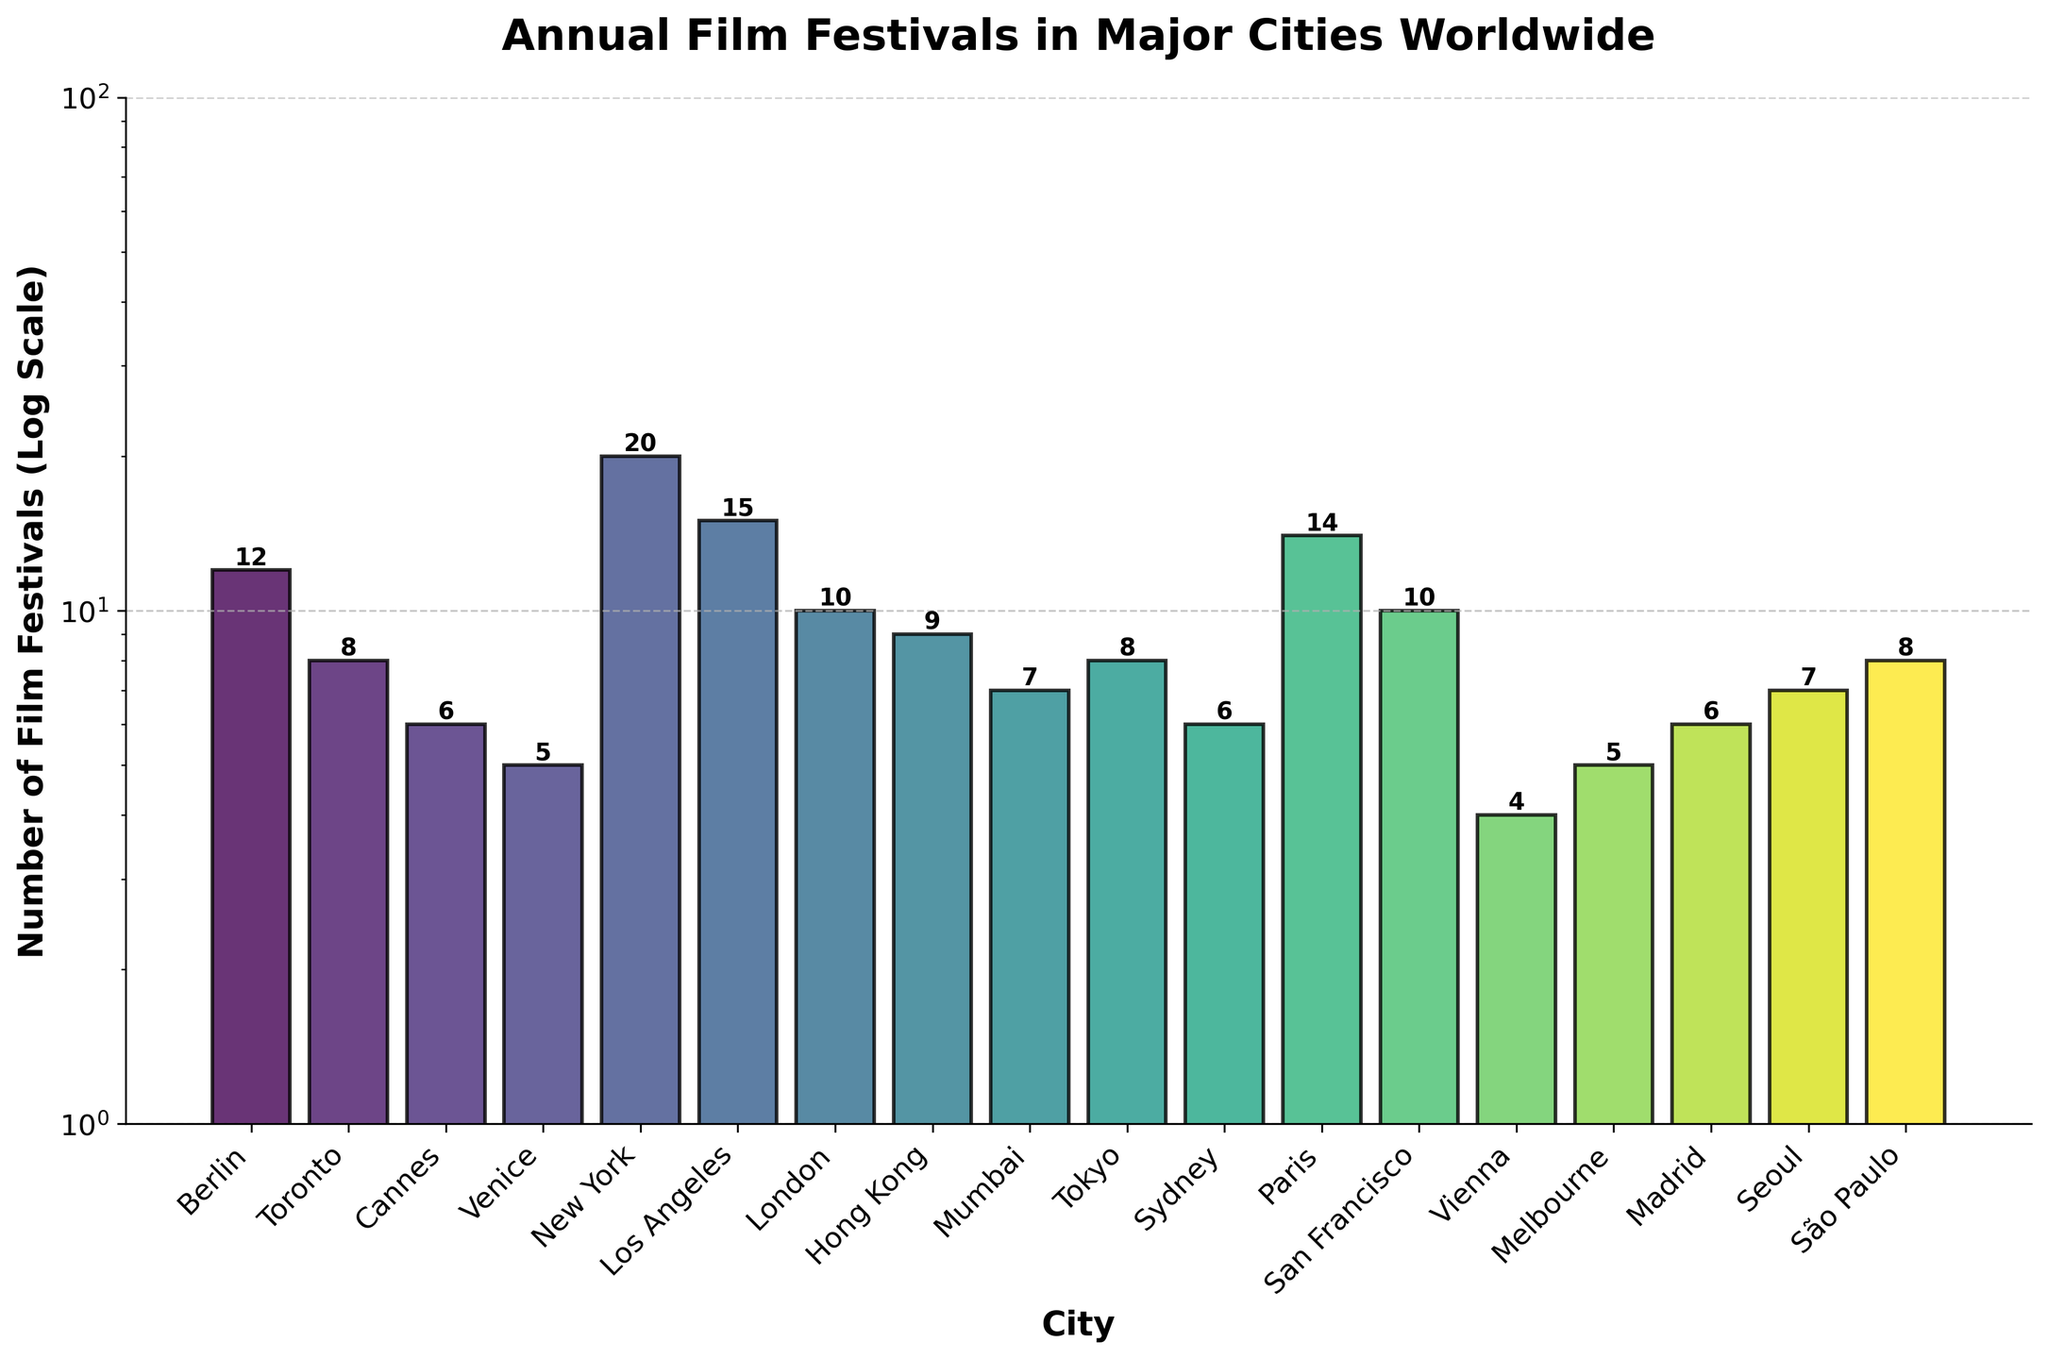What is the title of the plot? The title of the plot is displayed at the top of the figure in bold.
Answer: Annual Film Festivals in Major Cities Worldwide Which city has the highest number of film festivals annually? The tallest bar in the plot represents the city with the highest number of film festivals.
Answer: New York How many film festivals are held annually in Tokyo? The height of Tokyo's bar in the plot, along with the number label, indicates the count of film festivals.
Answer: 8 Which cities have fewer than 5 annual film festivals? Look for the bars that are below the '5' mark on the y-axis.
Answer: Vienna How many more film festivals does Paris have compared to Venice? Find the difference in the heights of the bars corresponding to Paris and Venice.
Answer: 9 What is the combined number of film festivals held annually in Berlin and Los Angeles? Sum the number of film festivals in Berlin and Los Angeles, as shown at the top of their respective bars.
Answer: 27 Which city has the closest number of film festivals to Hong Kong? Compare the bars vertically to find the one closest in height to the Hong Kong bar.
Answer: Tokyo How many cities have more than 10 annual film festivals? Count the number of bars that extend above the '10' mark on the y-axis.
Answer: 4 What is the relationship between the visual height of the bars and the actual number of festivals on a log scale? In a log scale plot, the visual height increases logarithmically rather than linearly, meaning each step represents a multiplication, not a simple addition.
Answer: Logarithmic relationship Which city has one less film festival annually than London? Locate London's bar and find the adjacent bars with one festival difference.
Answer: San Francisco 